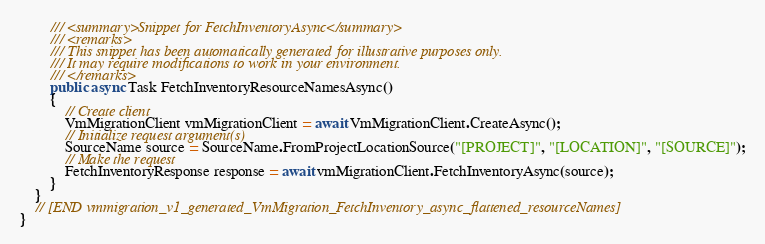Convert code to text. <code><loc_0><loc_0><loc_500><loc_500><_C#_>        /// <summary>Snippet for FetchInventoryAsync</summary>
        /// <remarks>
        /// This snippet has been automatically generated for illustrative purposes only.
        /// It may require modifications to work in your environment.
        /// </remarks>
        public async Task FetchInventoryResourceNamesAsync()
        {
            // Create client
            VmMigrationClient vmMigrationClient = await VmMigrationClient.CreateAsync();
            // Initialize request argument(s)
            SourceName source = SourceName.FromProjectLocationSource("[PROJECT]", "[LOCATION]", "[SOURCE]");
            // Make the request
            FetchInventoryResponse response = await vmMigrationClient.FetchInventoryAsync(source);
        }
    }
    // [END vmmigration_v1_generated_VmMigration_FetchInventory_async_flattened_resourceNames]
}
</code> 